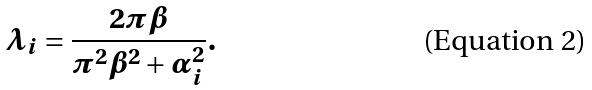Convert formula to latex. <formula><loc_0><loc_0><loc_500><loc_500>\lambda _ { i } = \frac { 2 \pi \beta } { \pi ^ { 2 } \beta ^ { 2 } + \alpha _ { i } ^ { 2 } } .</formula> 